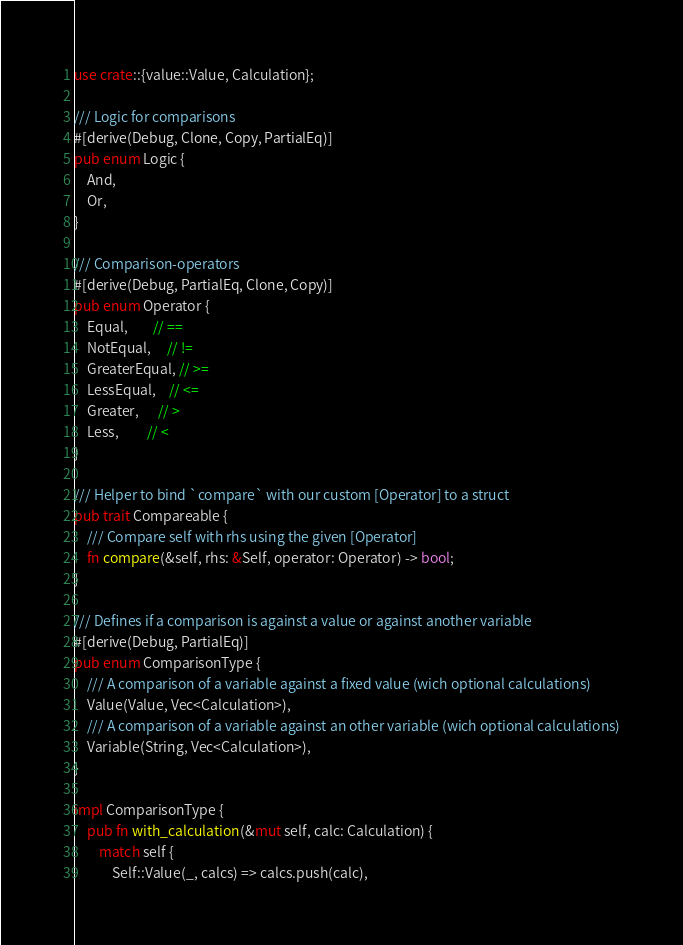<code> <loc_0><loc_0><loc_500><loc_500><_Rust_>use crate::{value::Value, Calculation};

/// Logic for comparisons
#[derive(Debug, Clone, Copy, PartialEq)]
pub enum Logic {
    And,
    Or,
}

/// Comparison-operators
#[derive(Debug, PartialEq, Clone, Copy)]
pub enum Operator {
    Equal,        // ==
    NotEqual,     // !=
    GreaterEqual, // >=
    LessEqual,    // <=
    Greater,      // >
    Less,         // <
}

/// Helper to bind `compare` with our custom [Operator] to a struct
pub trait Compareable {
    /// Compare self with rhs using the given [Operator]
    fn compare(&self, rhs: &Self, operator: Operator) -> bool;
}

/// Defines if a comparison is against a value or against another variable
#[derive(Debug, PartialEq)]
pub enum ComparisonType {
    /// A comparison of a variable against a fixed value (wich optional calculations)
    Value(Value, Vec<Calculation>),
    /// A comparison of a variable against an other variable (wich optional calculations)
    Variable(String, Vec<Calculation>),
}

impl ComparisonType {
    pub fn with_calculation(&mut self, calc: Calculation) {
        match self {
            Self::Value(_, calcs) => calcs.push(calc),</code> 